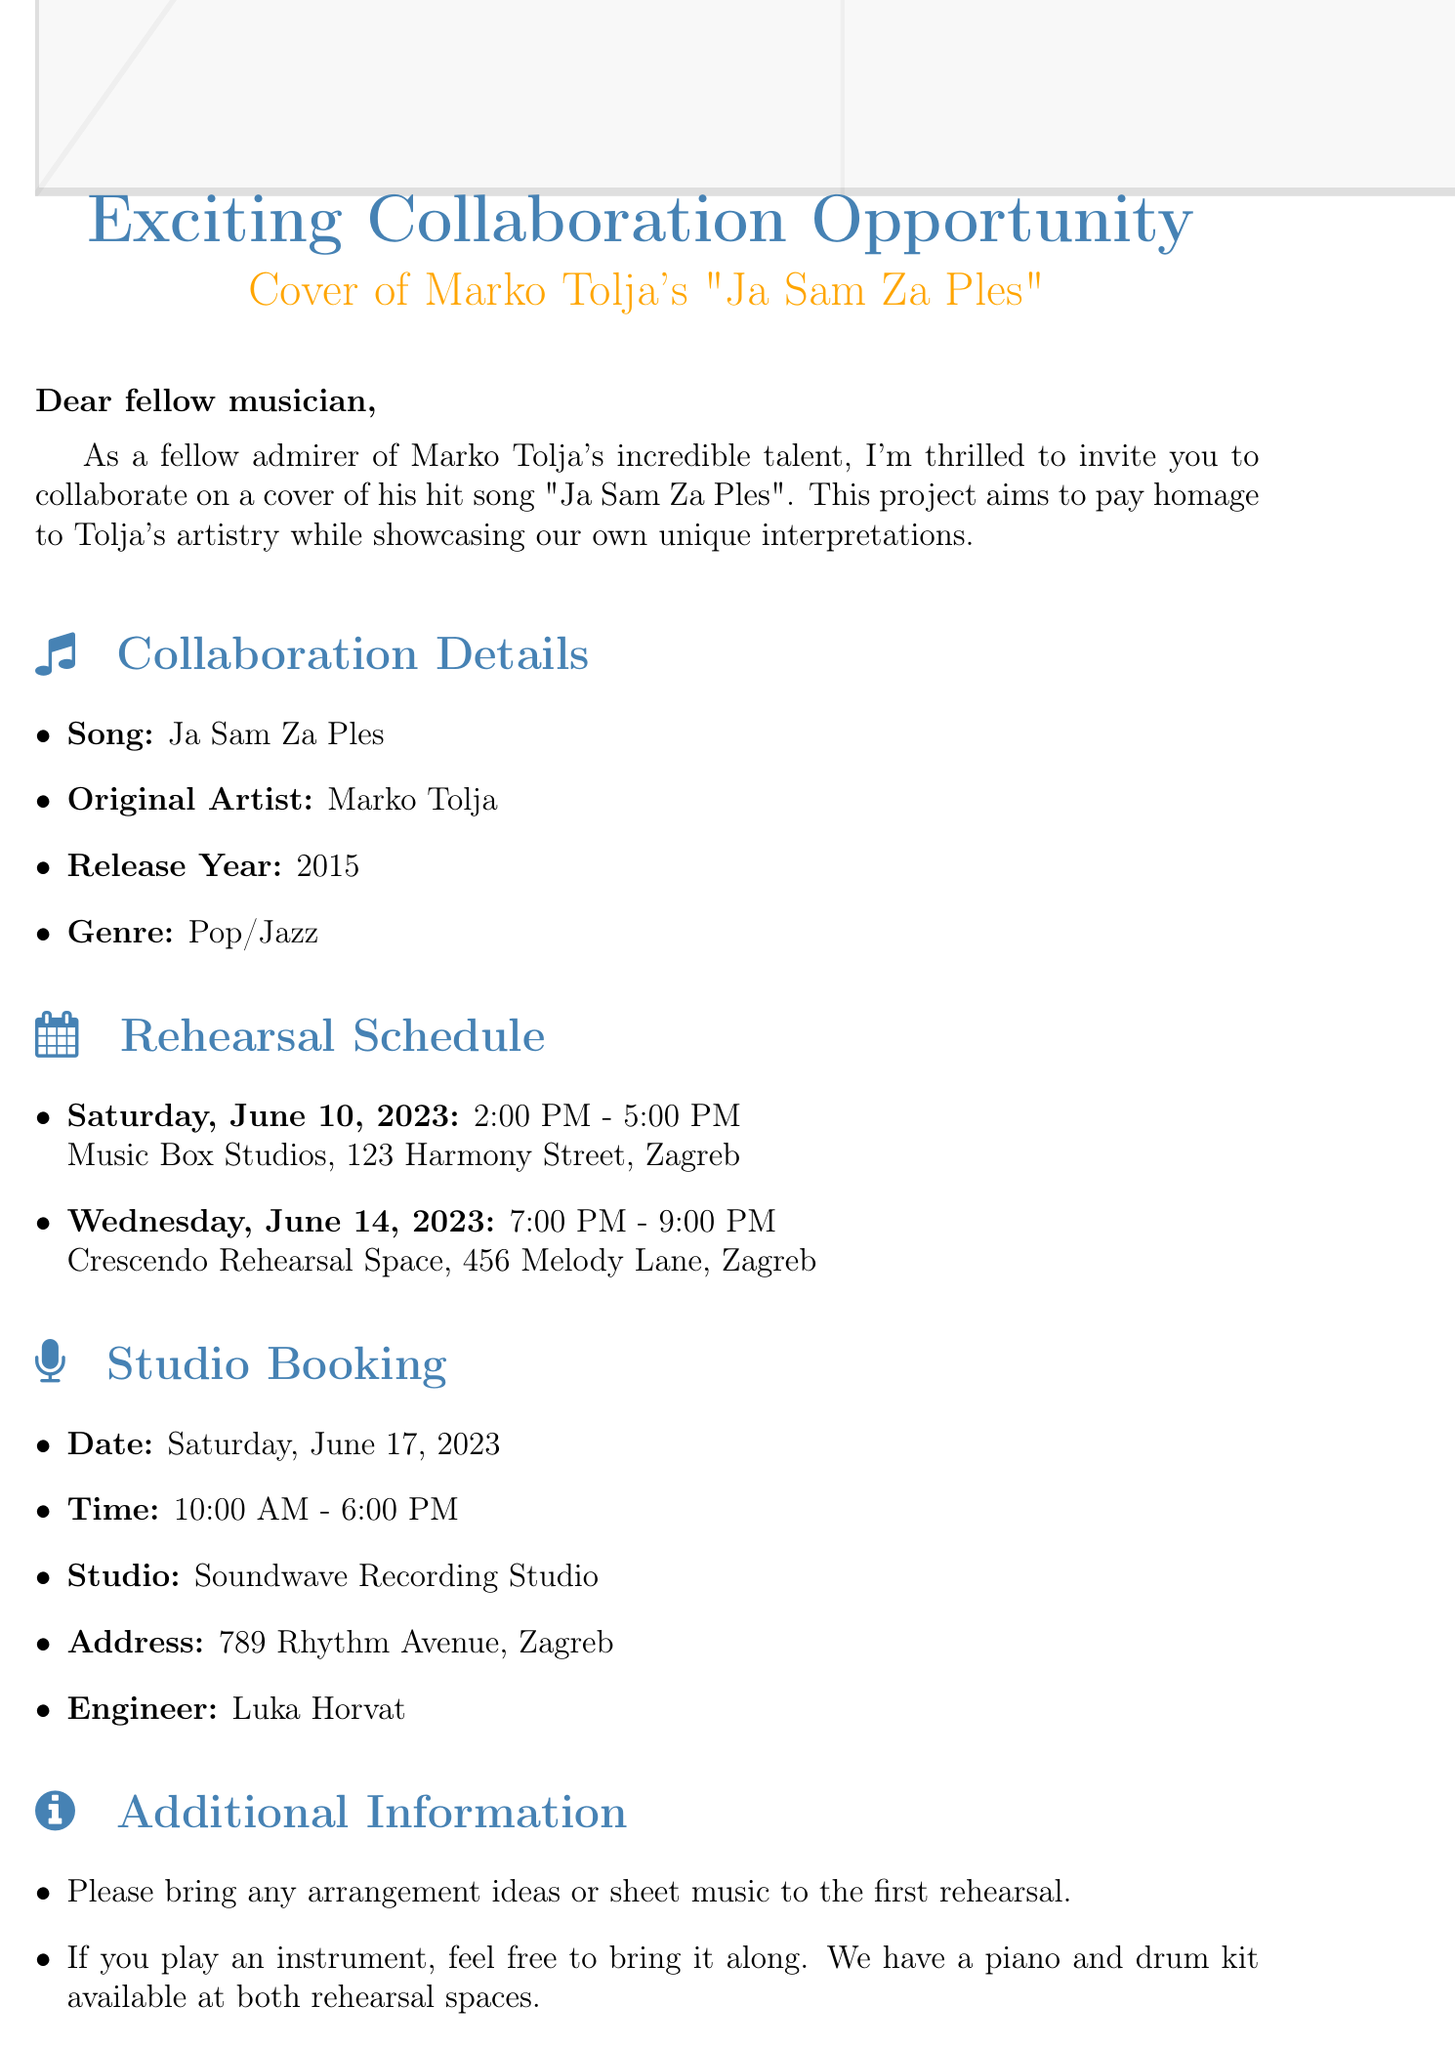what is the name of the song for the collaboration? The name of the song is specified in the collaboration details section of the document.
Answer: Ja Sam Za Ples who is the original artist of the song? The artist who originally performed the song is mentioned in the collaboration details section.
Answer: Marko Tolja what is the genre of "Ja Sam Za Ples"? The genre can be found in the collaboration details, providing a classification of the song.
Answer: Pop/Jazz when is the first rehearsal scheduled? The date and time for the first rehearsal are listed in the rehearsal schedule section.
Answer: Saturday, June 10, 2023 what is the address of the studio where recording will take place? The address of the recording studio is specified in the studio booking section of the document.
Answer: 789 Rhythm Avenue, Zagreb who is the engineer for the recording session? The name of the engineer is provided in the studio booking section and is crucial for the recording details.
Answer: Luka Horvat what should participants bring to the first rehearsal? A list of items to bring is provided in the additional information section of the email.
Answer: arrangement ideas or sheet music how long is the recording session scheduled for? The duration of the recording session can be inferred from the specified start and end times in the studio booking section.
Answer: 8 hours why is the collaboration being initiated? The reason for this collaboration opportunity is explained in the introduction of the email.
Answer: to pay homage to Tolja's artistry 